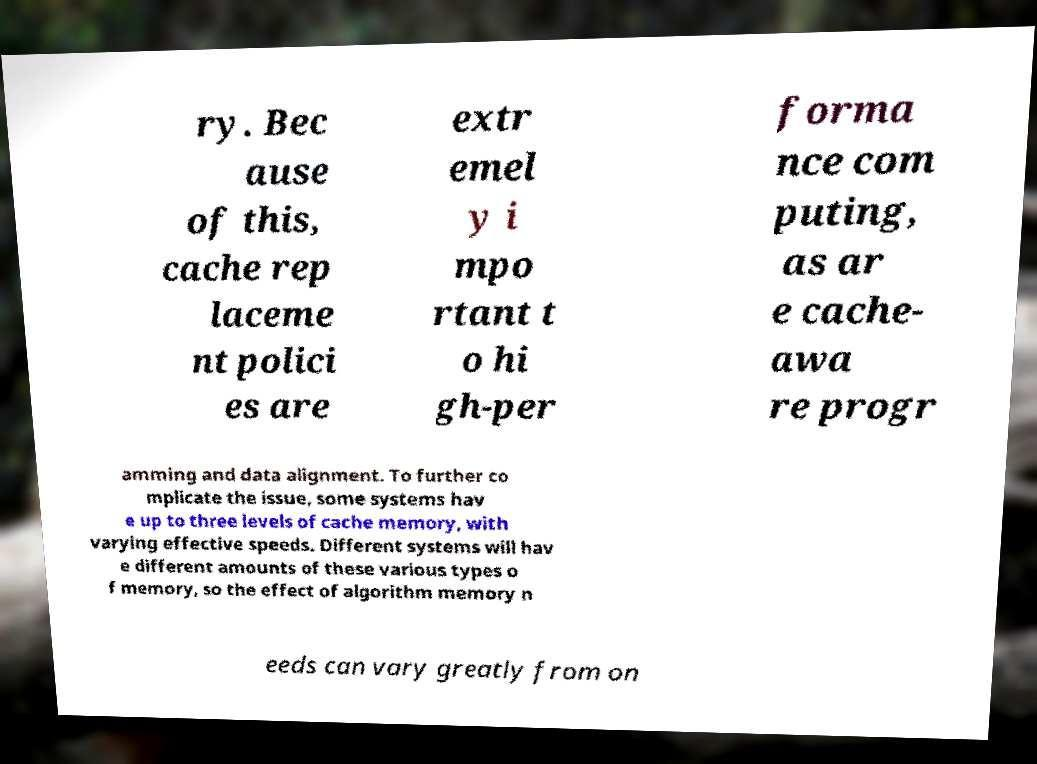Please read and relay the text visible in this image. What does it say? ry. Bec ause of this, cache rep laceme nt polici es are extr emel y i mpo rtant t o hi gh-per forma nce com puting, as ar e cache- awa re progr amming and data alignment. To further co mplicate the issue, some systems hav e up to three levels of cache memory, with varying effective speeds. Different systems will hav e different amounts of these various types o f memory, so the effect of algorithm memory n eeds can vary greatly from on 